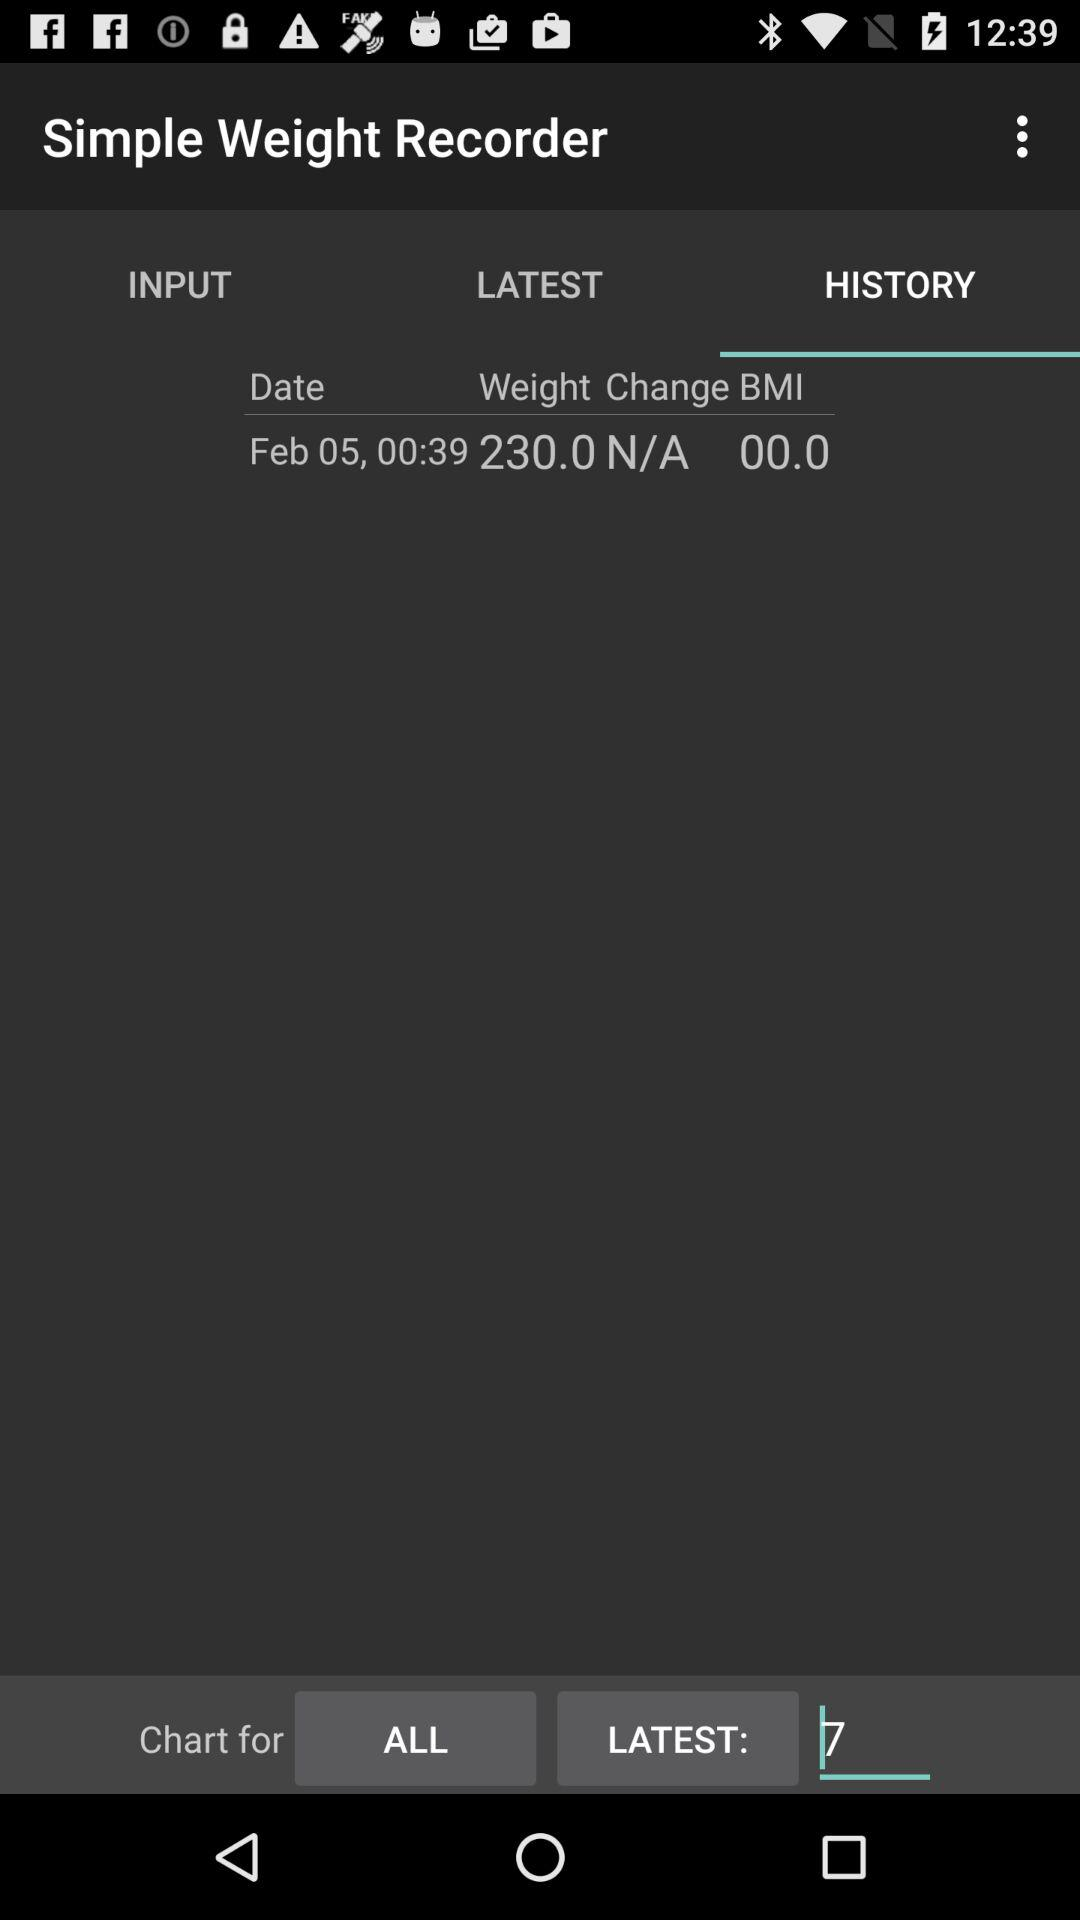What is the date of the entry with the highest weight change value?
Answer the question using a single word or phrase. Feb 05, 00:39 